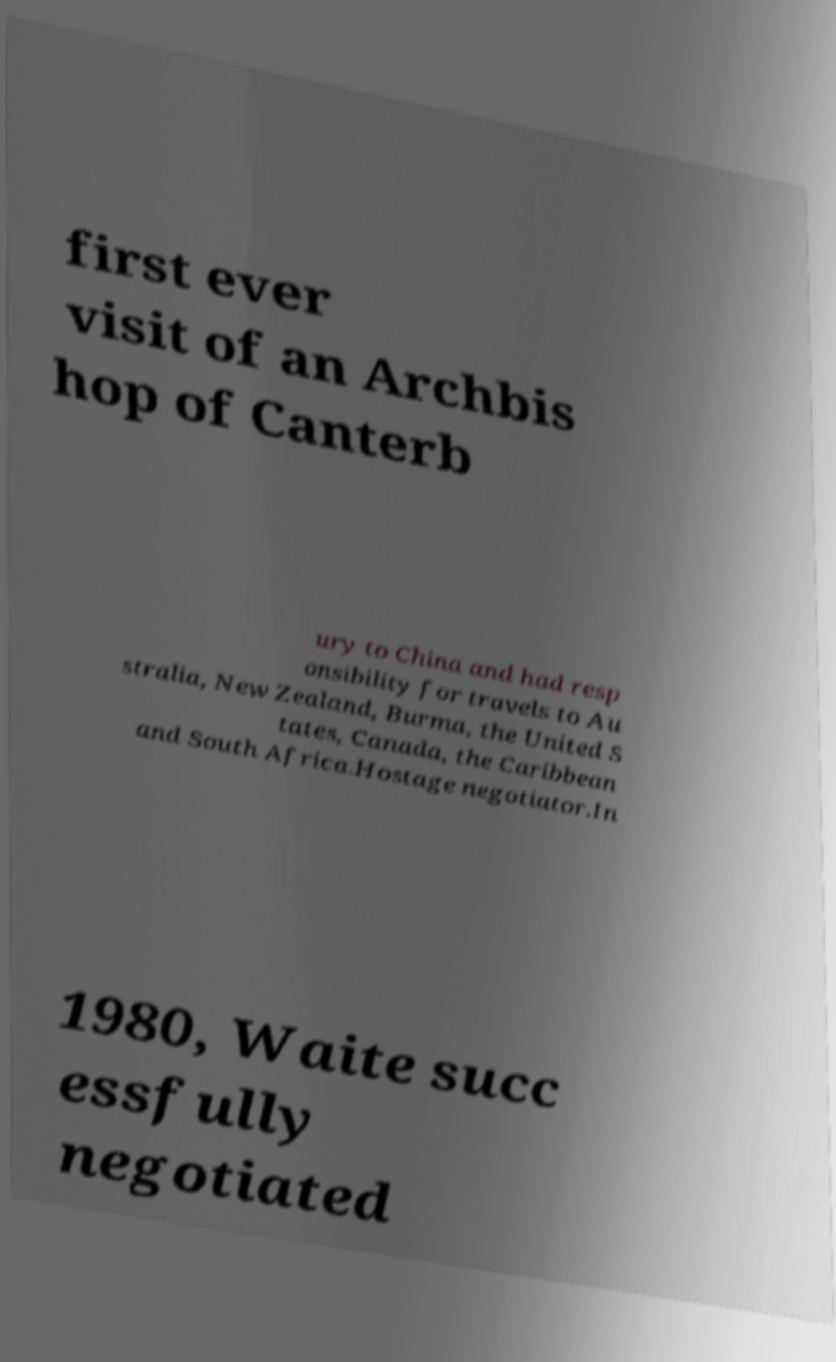Could you assist in decoding the text presented in this image and type it out clearly? first ever visit of an Archbis hop of Canterb ury to China and had resp onsibility for travels to Au stralia, New Zealand, Burma, the United S tates, Canada, the Caribbean and South Africa.Hostage negotiator.In 1980, Waite succ essfully negotiated 